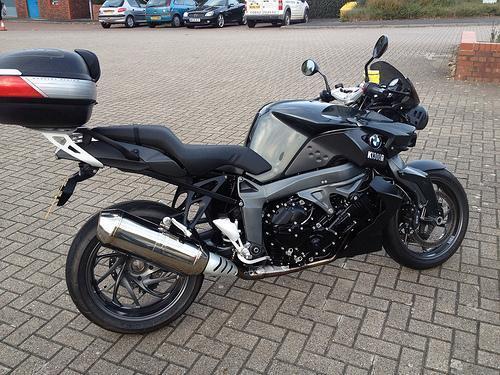How many motorcycles are pictured?
Give a very brief answer. 1. How many tires are on the motorcycle?
Give a very brief answer. 2. How many cars are in the background?
Give a very brief answer. 4. How many people could probably ride this motorcycle comfortably?
Give a very brief answer. 2. How many bikes are parked?
Give a very brief answer. 1. How many people are getting on the motor?
Give a very brief answer. 0. 